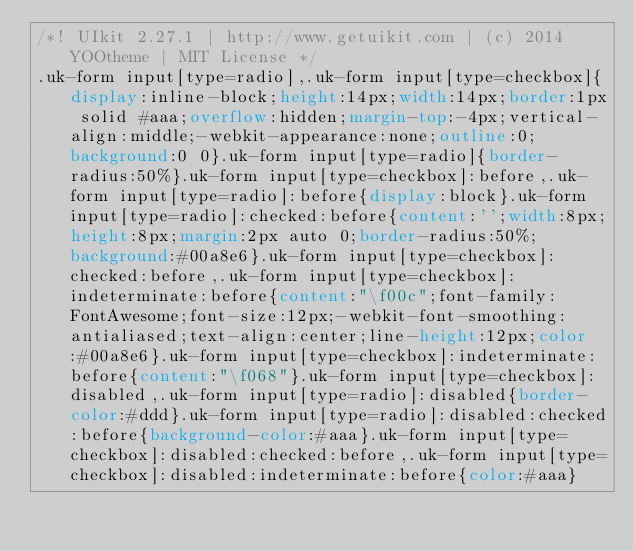Convert code to text. <code><loc_0><loc_0><loc_500><loc_500><_CSS_>/*! UIkit 2.27.1 | http://www.getuikit.com | (c) 2014 YOOtheme | MIT License */
.uk-form input[type=radio],.uk-form input[type=checkbox]{display:inline-block;height:14px;width:14px;border:1px solid #aaa;overflow:hidden;margin-top:-4px;vertical-align:middle;-webkit-appearance:none;outline:0;background:0 0}.uk-form input[type=radio]{border-radius:50%}.uk-form input[type=checkbox]:before,.uk-form input[type=radio]:before{display:block}.uk-form input[type=radio]:checked:before{content:'';width:8px;height:8px;margin:2px auto 0;border-radius:50%;background:#00a8e6}.uk-form input[type=checkbox]:checked:before,.uk-form input[type=checkbox]:indeterminate:before{content:"\f00c";font-family:FontAwesome;font-size:12px;-webkit-font-smoothing:antialiased;text-align:center;line-height:12px;color:#00a8e6}.uk-form input[type=checkbox]:indeterminate:before{content:"\f068"}.uk-form input[type=checkbox]:disabled,.uk-form input[type=radio]:disabled{border-color:#ddd}.uk-form input[type=radio]:disabled:checked:before{background-color:#aaa}.uk-form input[type=checkbox]:disabled:checked:before,.uk-form input[type=checkbox]:disabled:indeterminate:before{color:#aaa}</code> 